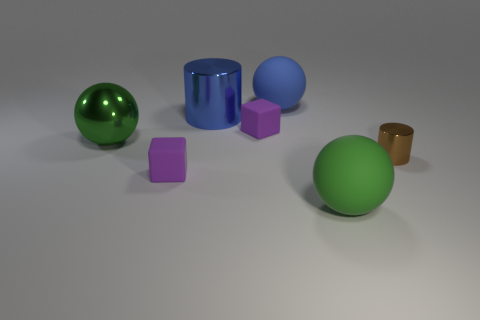The small metal thing is what color?
Offer a very short reply. Brown. Is there a green rubber object to the left of the ball left of the blue sphere?
Keep it short and to the point. No. What is the material of the blue sphere?
Provide a short and direct response. Rubber. Is the material of the purple thing left of the big blue cylinder the same as the cylinder that is behind the large green shiny sphere?
Make the answer very short. No. Are there any other things that have the same color as the large metal cylinder?
Give a very brief answer. Yes. The other thing that is the same shape as the large blue metallic thing is what color?
Offer a very short reply. Brown. What is the size of the sphere that is both in front of the blue matte object and behind the large green rubber thing?
Provide a short and direct response. Large. There is a purple matte object behind the large metallic sphere; does it have the same shape as the matte thing that is on the right side of the big blue ball?
Provide a short and direct response. No. The large thing that is the same color as the large metallic ball is what shape?
Your response must be concise. Sphere. How many tiny brown objects are made of the same material as the small brown cylinder?
Provide a succinct answer. 0. 